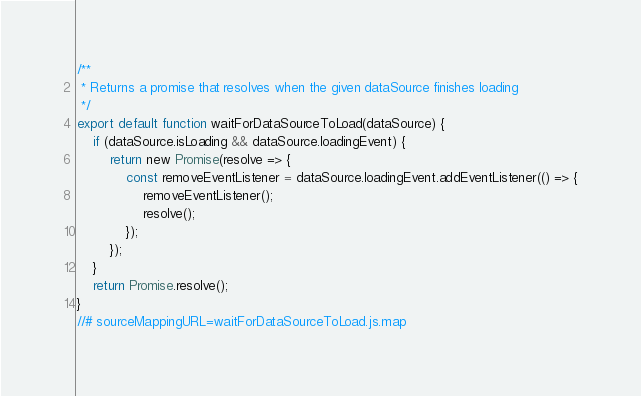<code> <loc_0><loc_0><loc_500><loc_500><_JavaScript_>/**
 * Returns a promise that resolves when the given dataSource finishes loading
 */
export default function waitForDataSourceToLoad(dataSource) {
    if (dataSource.isLoading && dataSource.loadingEvent) {
        return new Promise(resolve => {
            const removeEventListener = dataSource.loadingEvent.addEventListener(() => {
                removeEventListener();
                resolve();
            });
        });
    }
    return Promise.resolve();
}
//# sourceMappingURL=waitForDataSourceToLoad.js.map</code> 